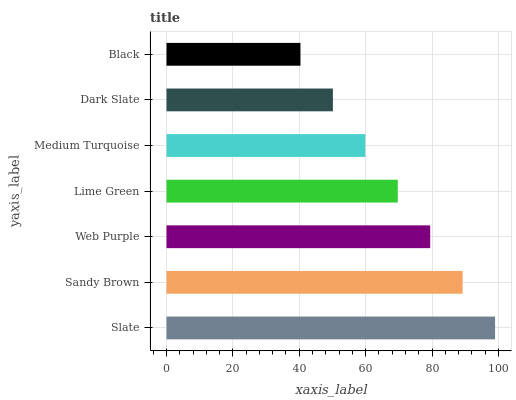Is Black the minimum?
Answer yes or no. Yes. Is Slate the maximum?
Answer yes or no. Yes. Is Sandy Brown the minimum?
Answer yes or no. No. Is Sandy Brown the maximum?
Answer yes or no. No. Is Slate greater than Sandy Brown?
Answer yes or no. Yes. Is Sandy Brown less than Slate?
Answer yes or no. Yes. Is Sandy Brown greater than Slate?
Answer yes or no. No. Is Slate less than Sandy Brown?
Answer yes or no. No. Is Lime Green the high median?
Answer yes or no. Yes. Is Lime Green the low median?
Answer yes or no. Yes. Is Sandy Brown the high median?
Answer yes or no. No. Is Sandy Brown the low median?
Answer yes or no. No. 